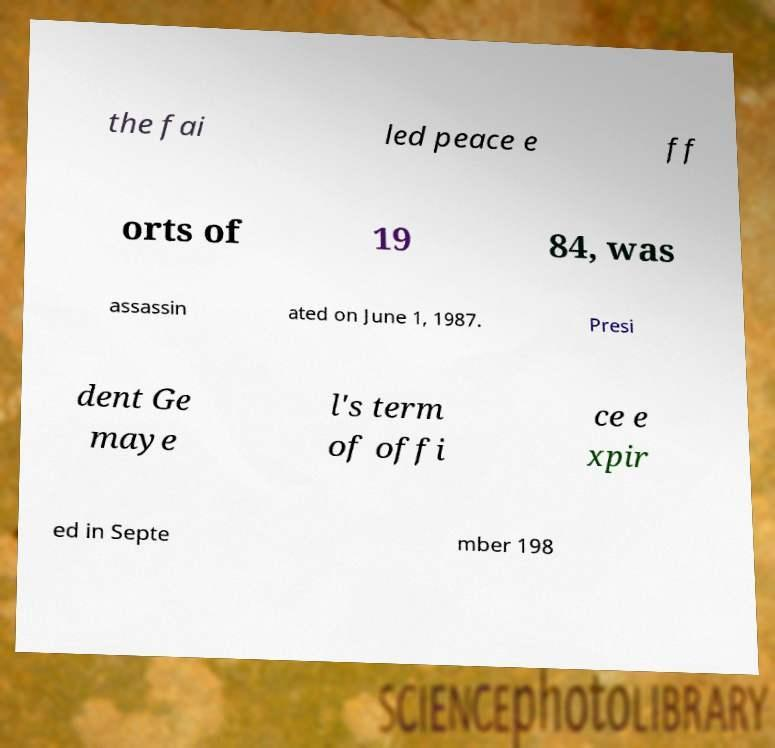Could you extract and type out the text from this image? the fai led peace e ff orts of 19 84, was assassin ated on June 1, 1987. Presi dent Ge maye l's term of offi ce e xpir ed in Septe mber 198 